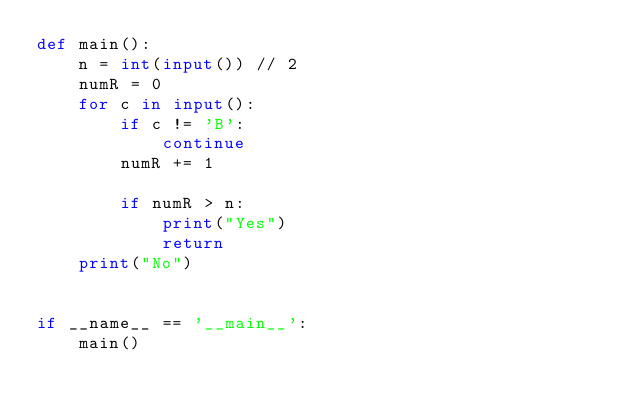Convert code to text. <code><loc_0><loc_0><loc_500><loc_500><_Python_>def main():
    n = int(input()) // 2
    numR = 0
    for c in input():
        if c != 'B':
            continue
        numR += 1

        if numR > n:
            print("Yes")
            return
    print("No")


if __name__ == '__main__':
    main()</code> 